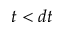<formula> <loc_0><loc_0><loc_500><loc_500>t < d t</formula> 